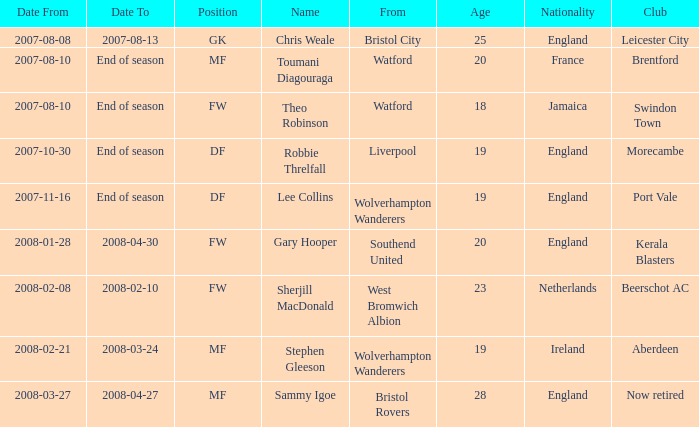What date did Toumani Diagouraga, who played position MF, start? 2007-08-10. 